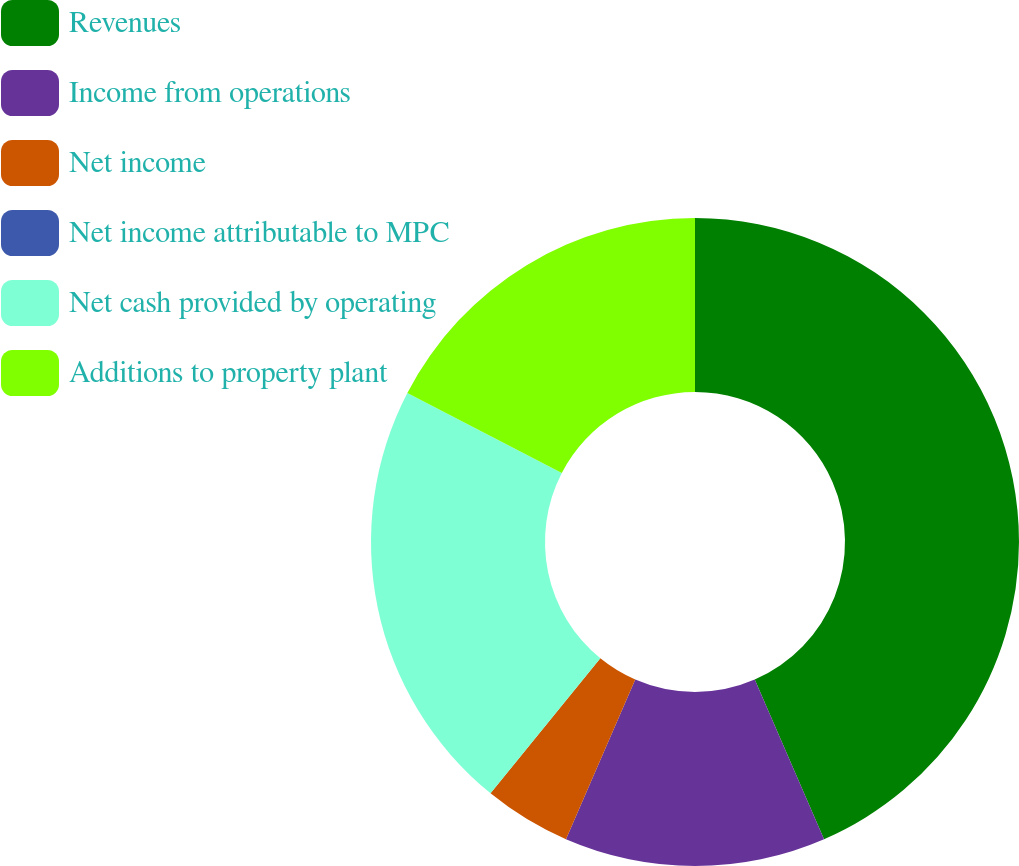<chart> <loc_0><loc_0><loc_500><loc_500><pie_chart><fcel>Revenues<fcel>Income from operations<fcel>Net income<fcel>Net income attributable to MPC<fcel>Net cash provided by operating<fcel>Additions to property plant<nl><fcel>43.48%<fcel>13.04%<fcel>4.35%<fcel>0.0%<fcel>21.74%<fcel>17.39%<nl></chart> 